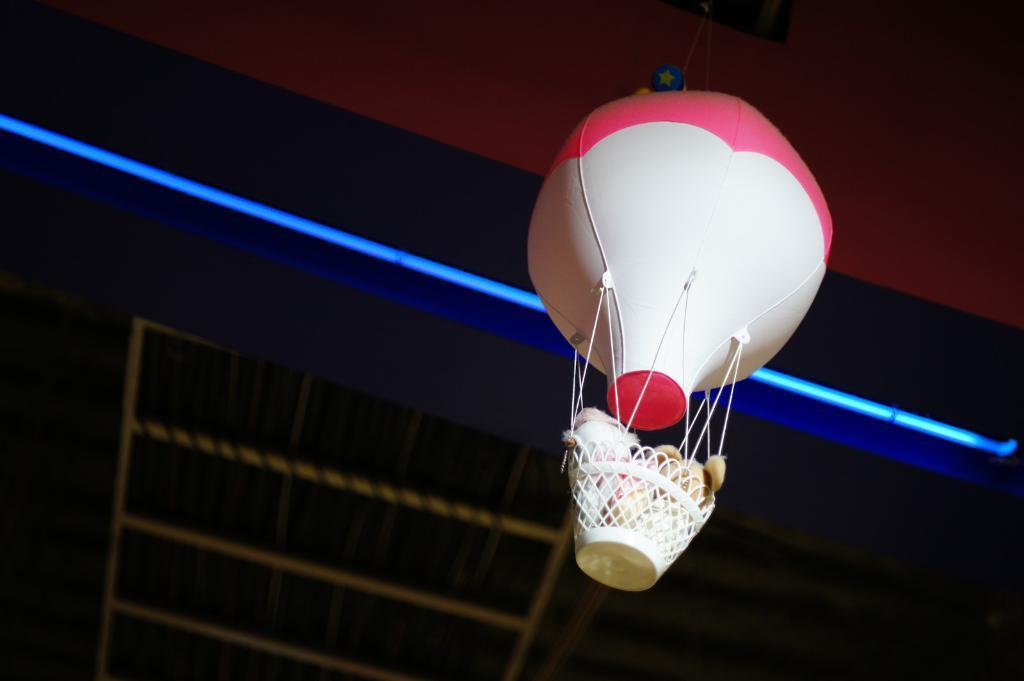Describe this image in one or two sentences. In this picture we can see a basket with a hot air balloon and in the basket there are toys. Behind the hot air balloon, at the top there is a light. 